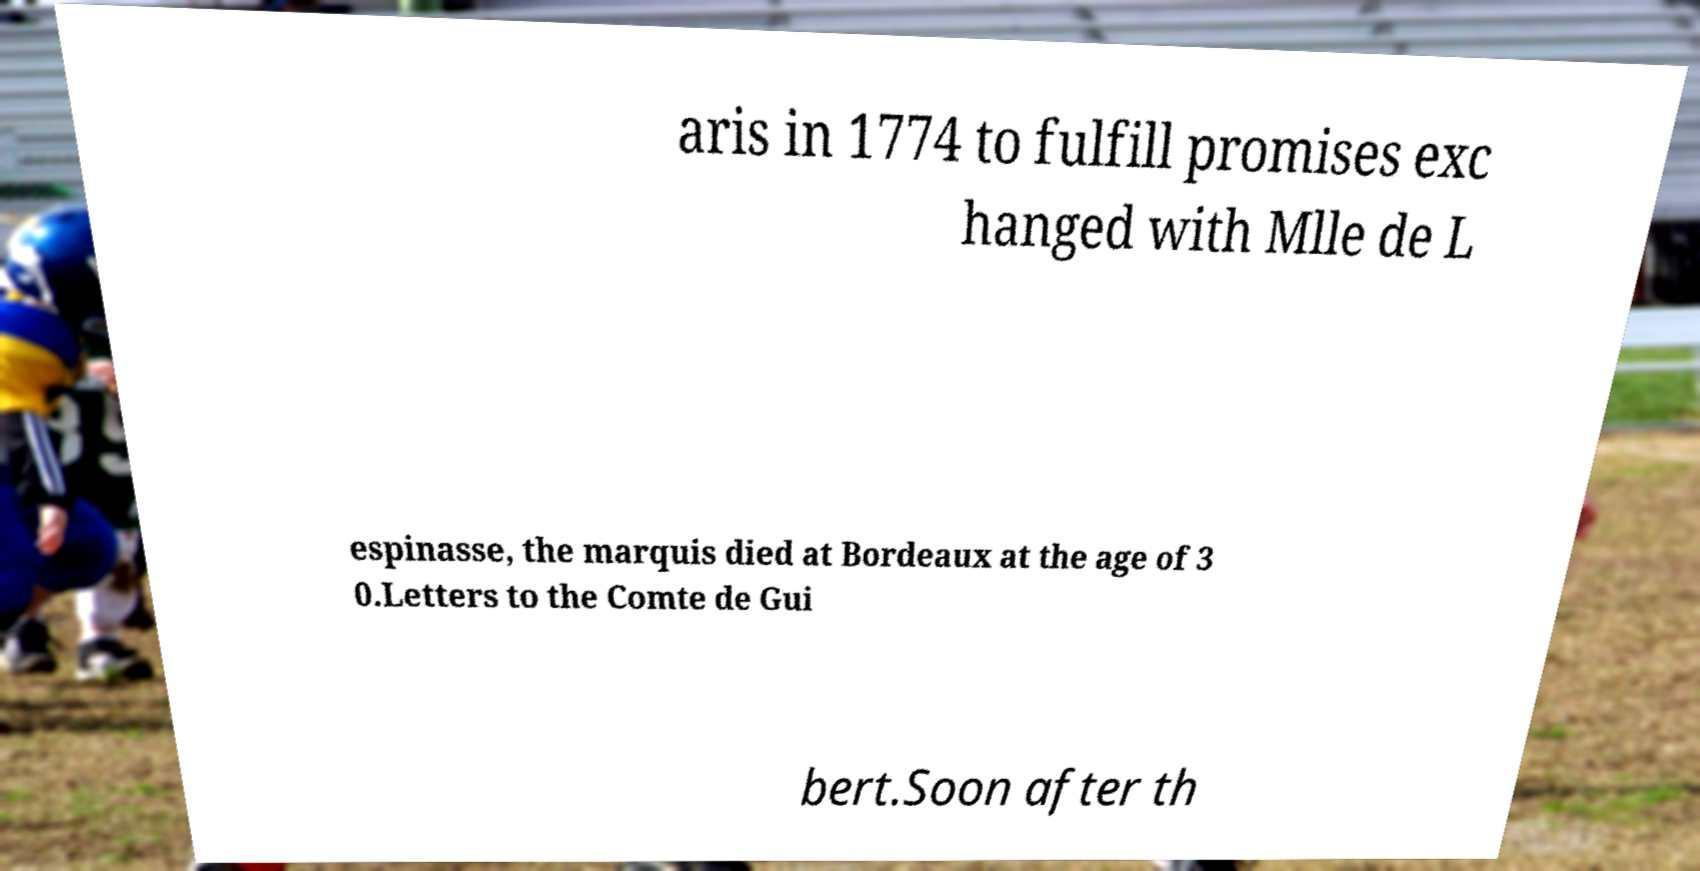There's text embedded in this image that I need extracted. Can you transcribe it verbatim? aris in 1774 to fulfill promises exc hanged with Mlle de L espinasse, the marquis died at Bordeaux at the age of 3 0.Letters to the Comte de Gui bert.Soon after th 